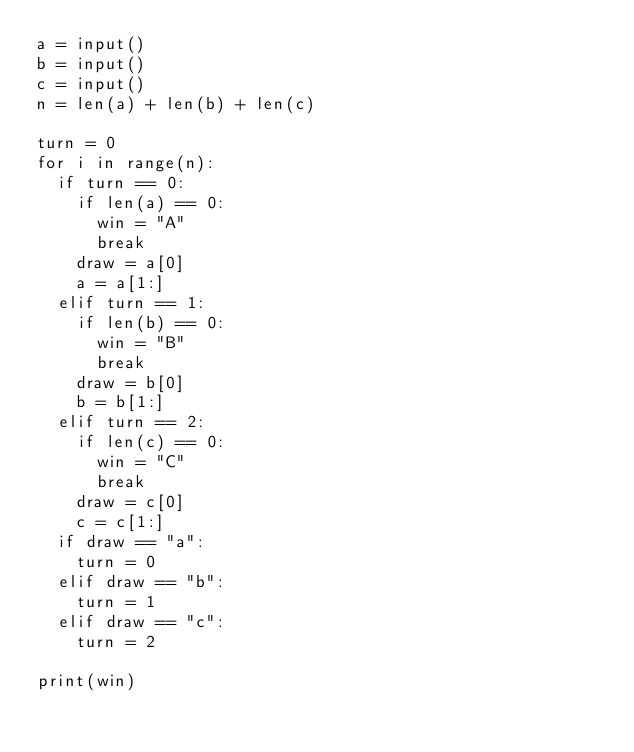Convert code to text. <code><loc_0><loc_0><loc_500><loc_500><_Python_>a = input()
b = input()
c = input()
n = len(a) + len(b) + len(c)

turn = 0
for i in range(n):
	if turn == 0:
		if len(a) == 0:
			win = "A"
			break
		draw = a[0]
		a = a[1:]
	elif turn == 1:
		if len(b) == 0:
			win = "B"
			break
		draw = b[0]
		b = b[1:]
	elif turn == 2:
		if len(c) == 0:
			win = "C"
			break
		draw = c[0]
		c = c[1:]
	if draw == "a":
		turn = 0
	elif draw == "b":
		turn = 1
	elif draw == "c":
		turn = 2

print(win)</code> 